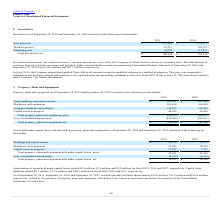From Plexus's financial document, Which years does the table provide information for Property, plant and equipment? The document shows two values: 2019 and 2018. From the document: "Inventories as of September 28, 2019 and September 29, 2018 consisted of the following (in thousands): tories as of September 28, 2019 and September 2..." Also, What was the amount of Land, buildings and improvements in 2018? According to the financial document, 267,809 (in thousands). The relevant text states: "Land, buildings and improvements $ 289,051 $ 267,809..." Also, What was the amount of Capital assets in progress in 2019? According to the financial document, 49,599 (in thousands). The relevant text states: "Capital assets in progress 49,599 38,469..." Additionally, Which years did Machinery and equipment exceed $300,000 thousand? The document shows two values: 2019 and 2018. From the document: "Inventories as of September 28, 2019 and September 29, 2018 consisted of the following (in thousands): tories as of September 28, 2019 and September 2..." Also, can you calculate: What was the change in Computer hardware and software between 2018 and 2019? Based on the calculation: 136,227-130,645, the result is 5582 (in thousands). This is based on the information: "Computer hardware and software 136,227 130,645 Computer hardware and software 136,227 130,645..." The key data points involved are: 130,645, 136,227. Also, can you calculate: What was the percentage change in the Capital assets in progress between 2018 and 2019? To answer this question, I need to perform calculations using the financial data. The calculation is: (49,599-38,469)/38,469, which equals 28.93 (percentage). This is based on the information: "Capital assets in progress 49,599 38,469 Capital assets in progress 49,599 38,469..." The key data points involved are: 38,469, 49,599. 